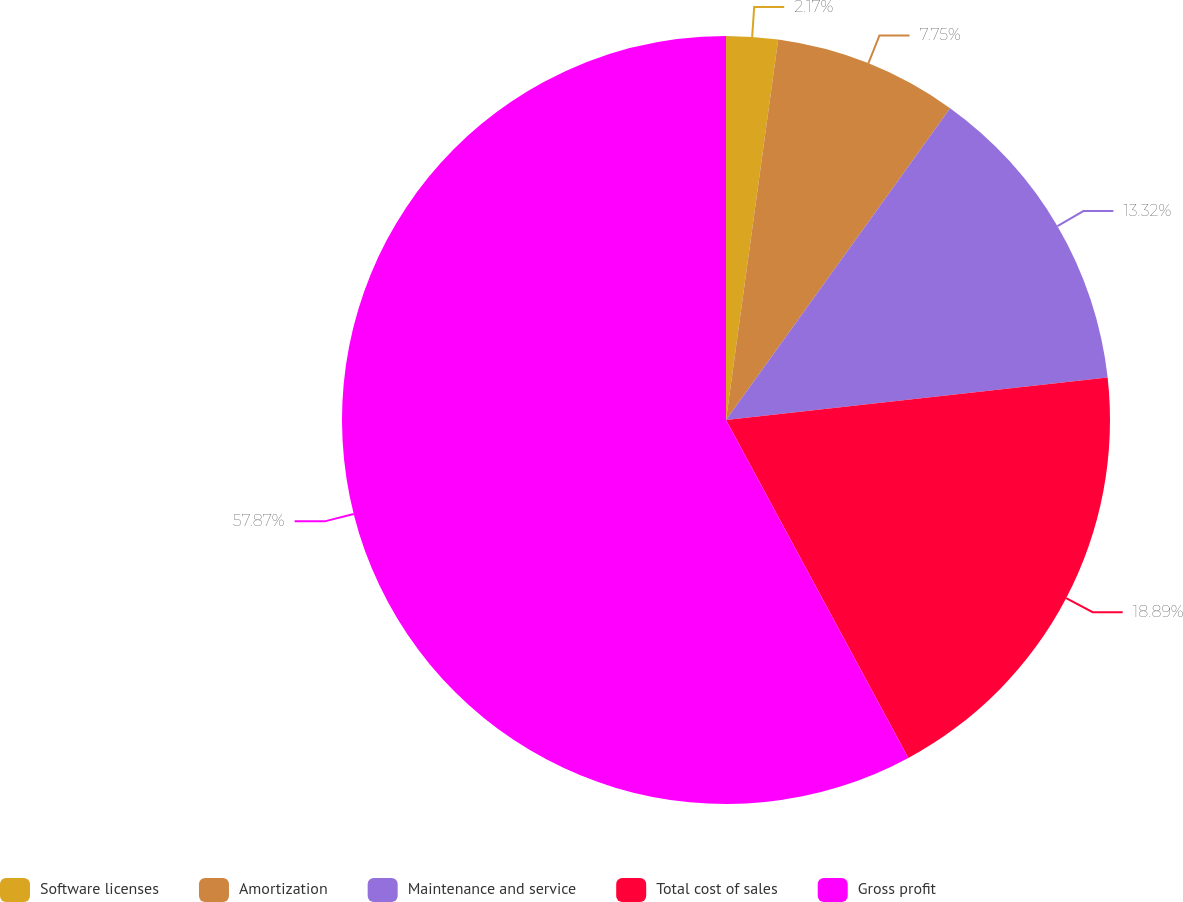<chart> <loc_0><loc_0><loc_500><loc_500><pie_chart><fcel>Software licenses<fcel>Amortization<fcel>Maintenance and service<fcel>Total cost of sales<fcel>Gross profit<nl><fcel>2.17%<fcel>7.75%<fcel>13.32%<fcel>18.89%<fcel>57.88%<nl></chart> 